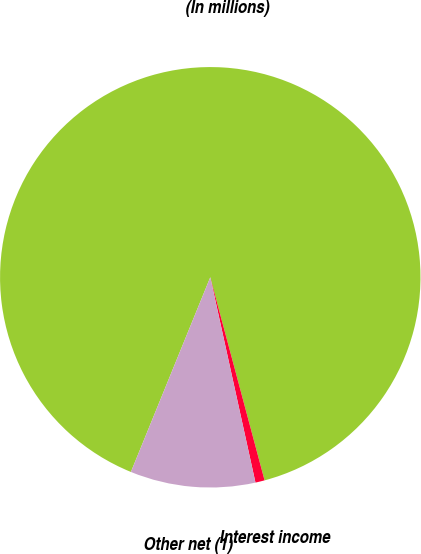Convert chart. <chart><loc_0><loc_0><loc_500><loc_500><pie_chart><fcel>(In millions)<fcel>Interest income<fcel>Other net (1)<nl><fcel>89.68%<fcel>0.71%<fcel>9.61%<nl></chart> 